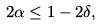<formula> <loc_0><loc_0><loc_500><loc_500>2 \alpha \leq 1 - 2 \delta ,</formula> 